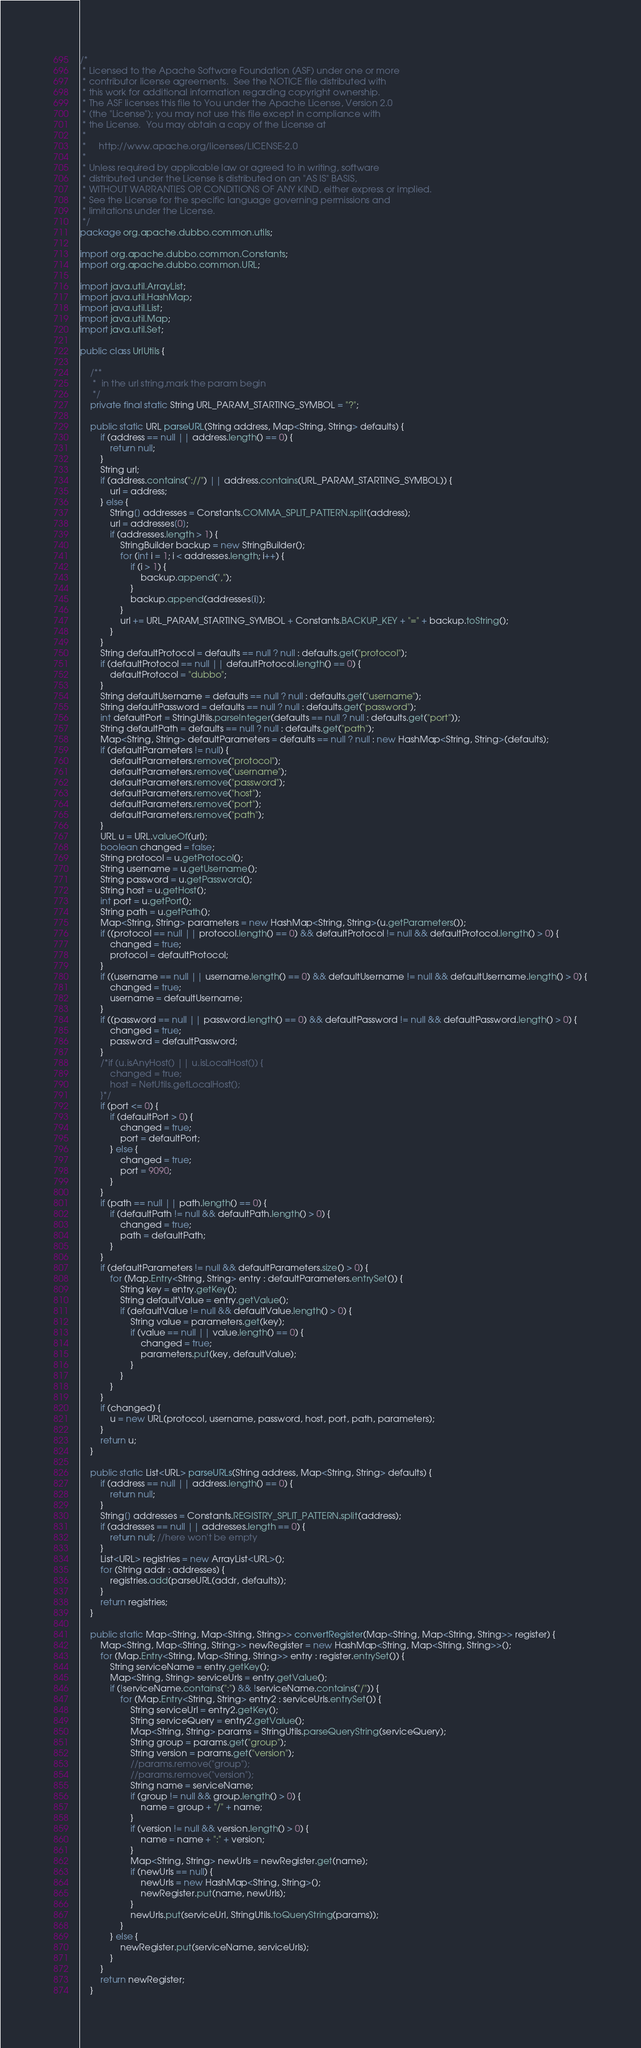<code> <loc_0><loc_0><loc_500><loc_500><_Java_>/*
 * Licensed to the Apache Software Foundation (ASF) under one or more
 * contributor license agreements.  See the NOTICE file distributed with
 * this work for additional information regarding copyright ownership.
 * The ASF licenses this file to You under the Apache License, Version 2.0
 * (the "License"); you may not use this file except in compliance with
 * the License.  You may obtain a copy of the License at
 *
 *     http://www.apache.org/licenses/LICENSE-2.0
 *
 * Unless required by applicable law or agreed to in writing, software
 * distributed under the License is distributed on an "AS IS" BASIS,
 * WITHOUT WARRANTIES OR CONDITIONS OF ANY KIND, either express or implied.
 * See the License for the specific language governing permissions and
 * limitations under the License.
 */
package org.apache.dubbo.common.utils;

import org.apache.dubbo.common.Constants;
import org.apache.dubbo.common.URL;

import java.util.ArrayList;
import java.util.HashMap;
import java.util.List;
import java.util.Map;
import java.util.Set;

public class UrlUtils {

    /**
     *  in the url string,mark the param begin
     */
    private final static String URL_PARAM_STARTING_SYMBOL = "?";

    public static URL parseURL(String address, Map<String, String> defaults) {
        if (address == null || address.length() == 0) {
            return null;
        }
        String url;
        if (address.contains("://") || address.contains(URL_PARAM_STARTING_SYMBOL)) {
            url = address;
        } else {
            String[] addresses = Constants.COMMA_SPLIT_PATTERN.split(address);
            url = addresses[0];
            if (addresses.length > 1) {
                StringBuilder backup = new StringBuilder();
                for (int i = 1; i < addresses.length; i++) {
                    if (i > 1) {
                        backup.append(",");
                    }
                    backup.append(addresses[i]);
                }
                url += URL_PARAM_STARTING_SYMBOL + Constants.BACKUP_KEY + "=" + backup.toString();
            }
        }
        String defaultProtocol = defaults == null ? null : defaults.get("protocol");
        if (defaultProtocol == null || defaultProtocol.length() == 0) {
            defaultProtocol = "dubbo";
        }
        String defaultUsername = defaults == null ? null : defaults.get("username");
        String defaultPassword = defaults == null ? null : defaults.get("password");
        int defaultPort = StringUtils.parseInteger(defaults == null ? null : defaults.get("port"));
        String defaultPath = defaults == null ? null : defaults.get("path");
        Map<String, String> defaultParameters = defaults == null ? null : new HashMap<String, String>(defaults);
        if (defaultParameters != null) {
            defaultParameters.remove("protocol");
            defaultParameters.remove("username");
            defaultParameters.remove("password");
            defaultParameters.remove("host");
            defaultParameters.remove("port");
            defaultParameters.remove("path");
        }
        URL u = URL.valueOf(url);
        boolean changed = false;
        String protocol = u.getProtocol();
        String username = u.getUsername();
        String password = u.getPassword();
        String host = u.getHost();
        int port = u.getPort();
        String path = u.getPath();
        Map<String, String> parameters = new HashMap<String, String>(u.getParameters());
        if ((protocol == null || protocol.length() == 0) && defaultProtocol != null && defaultProtocol.length() > 0) {
            changed = true;
            protocol = defaultProtocol;
        }
        if ((username == null || username.length() == 0) && defaultUsername != null && defaultUsername.length() > 0) {
            changed = true;
            username = defaultUsername;
        }
        if ((password == null || password.length() == 0) && defaultPassword != null && defaultPassword.length() > 0) {
            changed = true;
            password = defaultPassword;
        }
        /*if (u.isAnyHost() || u.isLocalHost()) {
            changed = true;
            host = NetUtils.getLocalHost();
        }*/
        if (port <= 0) {
            if (defaultPort > 0) {
                changed = true;
                port = defaultPort;
            } else {
                changed = true;
                port = 9090;
            }
        }
        if (path == null || path.length() == 0) {
            if (defaultPath != null && defaultPath.length() > 0) {
                changed = true;
                path = defaultPath;
            }
        }
        if (defaultParameters != null && defaultParameters.size() > 0) {
            for (Map.Entry<String, String> entry : defaultParameters.entrySet()) {
                String key = entry.getKey();
                String defaultValue = entry.getValue();
                if (defaultValue != null && defaultValue.length() > 0) {
                    String value = parameters.get(key);
                    if (value == null || value.length() == 0) {
                        changed = true;
                        parameters.put(key, defaultValue);
                    }
                }
            }
        }
        if (changed) {
            u = new URL(protocol, username, password, host, port, path, parameters);
        }
        return u;
    }

    public static List<URL> parseURLs(String address, Map<String, String> defaults) {
        if (address == null || address.length() == 0) {
            return null;
        }
        String[] addresses = Constants.REGISTRY_SPLIT_PATTERN.split(address);
        if (addresses == null || addresses.length == 0) {
            return null; //here won't be empty
        }
        List<URL> registries = new ArrayList<URL>();
        for (String addr : addresses) {
            registries.add(parseURL(addr, defaults));
        }
        return registries;
    }

    public static Map<String, Map<String, String>> convertRegister(Map<String, Map<String, String>> register) {
        Map<String, Map<String, String>> newRegister = new HashMap<String, Map<String, String>>();
        for (Map.Entry<String, Map<String, String>> entry : register.entrySet()) {
            String serviceName = entry.getKey();
            Map<String, String> serviceUrls = entry.getValue();
            if (!serviceName.contains(":") && !serviceName.contains("/")) {
                for (Map.Entry<String, String> entry2 : serviceUrls.entrySet()) {
                    String serviceUrl = entry2.getKey();
                    String serviceQuery = entry2.getValue();
                    Map<String, String> params = StringUtils.parseQueryString(serviceQuery);
                    String group = params.get("group");
                    String version = params.get("version");
                    //params.remove("group");
                    //params.remove("version");
                    String name = serviceName;
                    if (group != null && group.length() > 0) {
                        name = group + "/" + name;
                    }
                    if (version != null && version.length() > 0) {
                        name = name + ":" + version;
                    }
                    Map<String, String> newUrls = newRegister.get(name);
                    if (newUrls == null) {
                        newUrls = new HashMap<String, String>();
                        newRegister.put(name, newUrls);
                    }
                    newUrls.put(serviceUrl, StringUtils.toQueryString(params));
                }
            } else {
                newRegister.put(serviceName, serviceUrls);
            }
        }
        return newRegister;
    }
</code> 